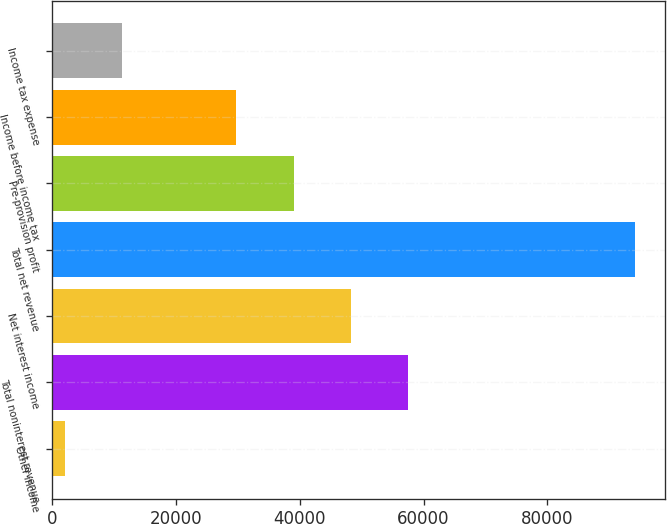<chart> <loc_0><loc_0><loc_500><loc_500><bar_chart><fcel>Other income<fcel>Total noninterest revenue<fcel>Net interest income<fcel>Total net revenue<fcel>Pre-provision profit<fcel>Income before income tax<fcel>Income tax expense<nl><fcel>2106<fcel>57421.7<fcel>48211.8<fcel>94205<fcel>39001.9<fcel>29792<fcel>11315.9<nl></chart> 